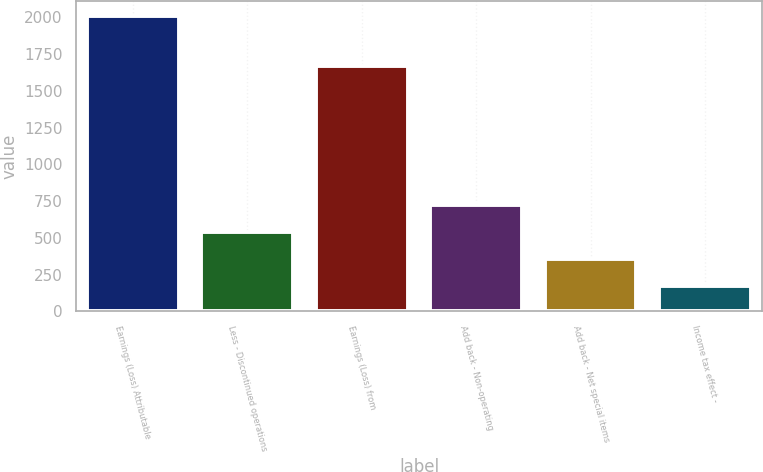<chart> <loc_0><loc_0><loc_500><loc_500><bar_chart><fcel>Earnings (Loss) Attributable<fcel>Less - Discontinued operations<fcel>Earnings (Loss) from<fcel>Add back - Non-operating<fcel>Add back - Net special items<fcel>Income tax effect -<nl><fcel>2012<fcel>539.2<fcel>1667<fcel>723.3<fcel>355.1<fcel>171<nl></chart> 